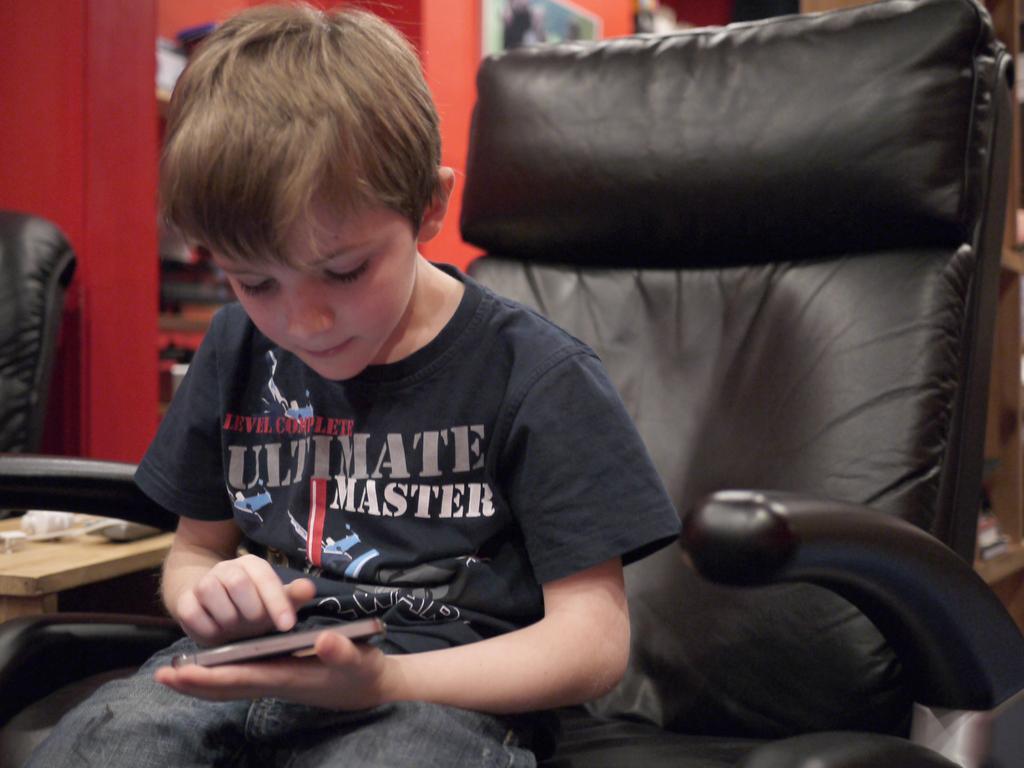Describe this image in one or two sentences. In this picture there is a boy playing with a mobile, sitting in the chair. In the background there is a wall. 